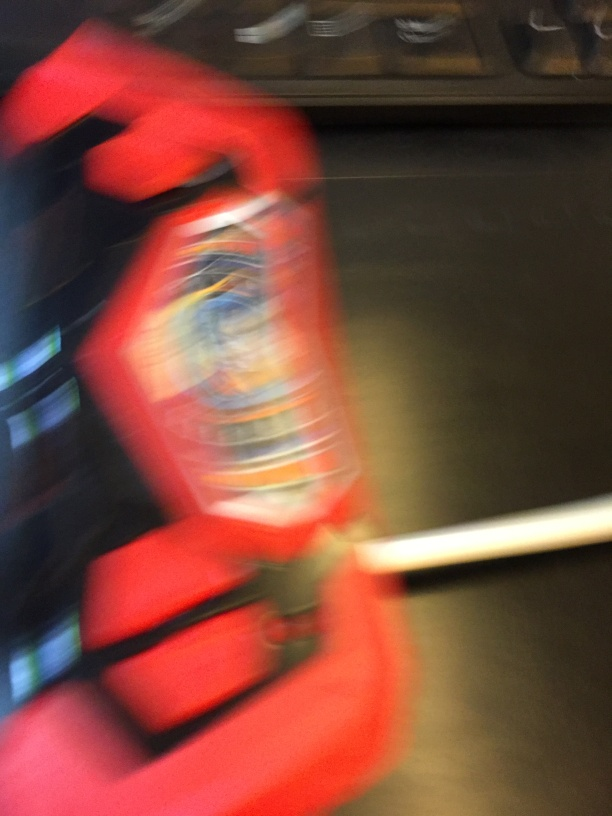What might be the reason for the blur in this image? The blur could be due to a quick movement of the camera or the object while the photo was taken, a slow shutter speed on the camera, or an intentional artistic choice to convey a sense of motion. Could you tell me what the object in the image might be? Although the image is blurred, the vivid red color and recognisable shape suggest that it could be a fire extinguisher, commonly found in buildings for safety purposes. 